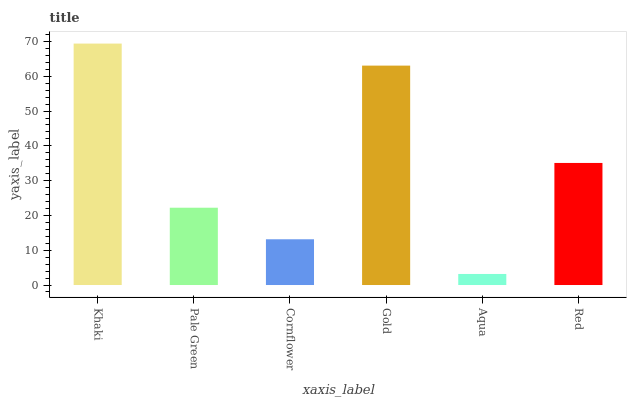Is Aqua the minimum?
Answer yes or no. Yes. Is Khaki the maximum?
Answer yes or no. Yes. Is Pale Green the minimum?
Answer yes or no. No. Is Pale Green the maximum?
Answer yes or no. No. Is Khaki greater than Pale Green?
Answer yes or no. Yes. Is Pale Green less than Khaki?
Answer yes or no. Yes. Is Pale Green greater than Khaki?
Answer yes or no. No. Is Khaki less than Pale Green?
Answer yes or no. No. Is Red the high median?
Answer yes or no. Yes. Is Pale Green the low median?
Answer yes or no. Yes. Is Khaki the high median?
Answer yes or no. No. Is Gold the low median?
Answer yes or no. No. 